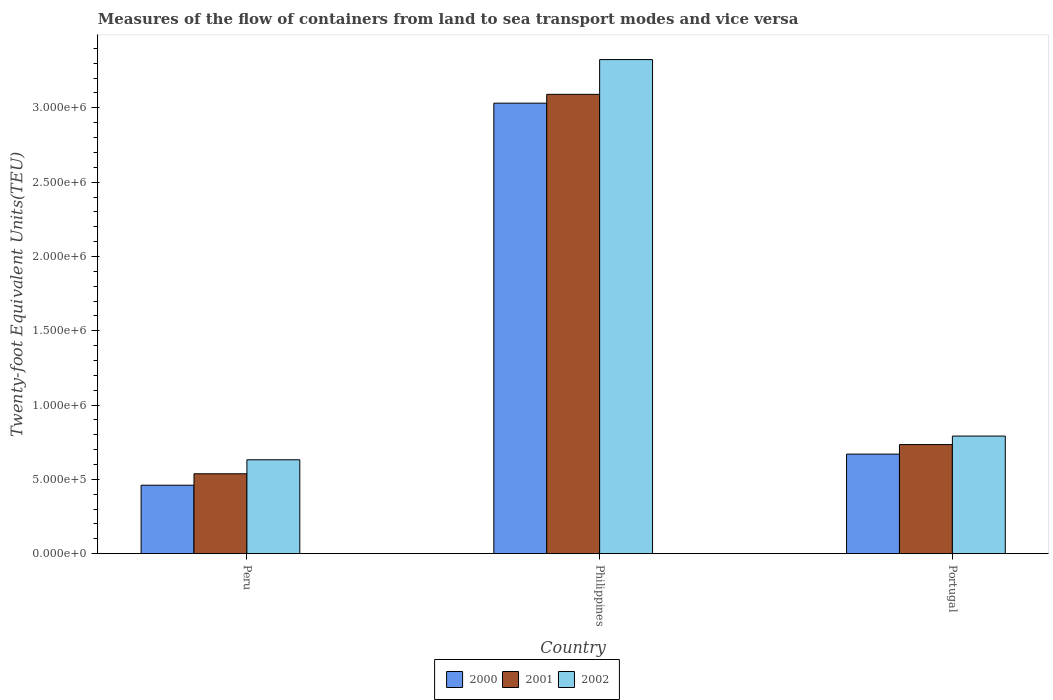How many different coloured bars are there?
Your answer should be compact. 3. Are the number of bars on each tick of the X-axis equal?
Ensure brevity in your answer.  Yes. How many bars are there on the 2nd tick from the left?
Provide a succinct answer. 3. How many bars are there on the 2nd tick from the right?
Your response must be concise. 3. What is the label of the 1st group of bars from the left?
Your answer should be very brief. Peru. What is the container port traffic in 2001 in Portugal?
Provide a short and direct response. 7.34e+05. Across all countries, what is the maximum container port traffic in 2000?
Offer a very short reply. 3.03e+06. Across all countries, what is the minimum container port traffic in 2002?
Your answer should be very brief. 6.32e+05. In which country was the container port traffic in 2001 maximum?
Your answer should be compact. Philippines. In which country was the container port traffic in 2001 minimum?
Provide a succinct answer. Peru. What is the total container port traffic in 2001 in the graph?
Keep it short and to the point. 4.36e+06. What is the difference between the container port traffic in 2000 in Peru and that in Philippines?
Offer a terse response. -2.57e+06. What is the difference between the container port traffic in 2002 in Peru and the container port traffic in 2001 in Portugal?
Offer a very short reply. -1.02e+05. What is the average container port traffic in 2000 per country?
Ensure brevity in your answer.  1.39e+06. What is the difference between the container port traffic of/in 2002 and container port traffic of/in 2000 in Peru?
Provide a short and direct response. 1.71e+05. What is the ratio of the container port traffic in 2000 in Peru to that in Philippines?
Offer a very short reply. 0.15. Is the difference between the container port traffic in 2002 in Peru and Portugal greater than the difference between the container port traffic in 2000 in Peru and Portugal?
Your answer should be very brief. Yes. What is the difference between the highest and the second highest container port traffic in 2000?
Offer a terse response. 2.57e+06. What is the difference between the highest and the lowest container port traffic in 2001?
Your response must be concise. 2.55e+06. Is the sum of the container port traffic in 2002 in Philippines and Portugal greater than the maximum container port traffic in 2000 across all countries?
Provide a succinct answer. Yes. What is the difference between two consecutive major ticks on the Y-axis?
Offer a very short reply. 5.00e+05. Are the values on the major ticks of Y-axis written in scientific E-notation?
Make the answer very short. Yes. Does the graph contain any zero values?
Make the answer very short. No. Does the graph contain grids?
Your answer should be very brief. No. Where does the legend appear in the graph?
Your answer should be compact. Bottom center. How many legend labels are there?
Ensure brevity in your answer.  3. What is the title of the graph?
Make the answer very short. Measures of the flow of containers from land to sea transport modes and vice versa. What is the label or title of the X-axis?
Your answer should be compact. Country. What is the label or title of the Y-axis?
Provide a succinct answer. Twenty-foot Equivalent Units(TEU). What is the Twenty-foot Equivalent Units(TEU) in 2000 in Peru?
Ensure brevity in your answer.  4.61e+05. What is the Twenty-foot Equivalent Units(TEU) in 2001 in Peru?
Ensure brevity in your answer.  5.38e+05. What is the Twenty-foot Equivalent Units(TEU) in 2002 in Peru?
Keep it short and to the point. 6.32e+05. What is the Twenty-foot Equivalent Units(TEU) in 2000 in Philippines?
Offer a very short reply. 3.03e+06. What is the Twenty-foot Equivalent Units(TEU) of 2001 in Philippines?
Provide a succinct answer. 3.09e+06. What is the Twenty-foot Equivalent Units(TEU) in 2002 in Philippines?
Offer a very short reply. 3.32e+06. What is the Twenty-foot Equivalent Units(TEU) of 2000 in Portugal?
Give a very brief answer. 6.70e+05. What is the Twenty-foot Equivalent Units(TEU) of 2001 in Portugal?
Make the answer very short. 7.34e+05. What is the Twenty-foot Equivalent Units(TEU) of 2002 in Portugal?
Provide a short and direct response. 7.91e+05. Across all countries, what is the maximum Twenty-foot Equivalent Units(TEU) of 2000?
Your answer should be compact. 3.03e+06. Across all countries, what is the maximum Twenty-foot Equivalent Units(TEU) in 2001?
Give a very brief answer. 3.09e+06. Across all countries, what is the maximum Twenty-foot Equivalent Units(TEU) of 2002?
Make the answer very short. 3.32e+06. Across all countries, what is the minimum Twenty-foot Equivalent Units(TEU) of 2000?
Provide a short and direct response. 4.61e+05. Across all countries, what is the minimum Twenty-foot Equivalent Units(TEU) of 2001?
Your answer should be very brief. 5.38e+05. Across all countries, what is the minimum Twenty-foot Equivalent Units(TEU) of 2002?
Give a very brief answer. 6.32e+05. What is the total Twenty-foot Equivalent Units(TEU) of 2000 in the graph?
Make the answer very short. 4.16e+06. What is the total Twenty-foot Equivalent Units(TEU) in 2001 in the graph?
Provide a succinct answer. 4.36e+06. What is the total Twenty-foot Equivalent Units(TEU) of 2002 in the graph?
Offer a very short reply. 4.75e+06. What is the difference between the Twenty-foot Equivalent Units(TEU) in 2000 in Peru and that in Philippines?
Offer a terse response. -2.57e+06. What is the difference between the Twenty-foot Equivalent Units(TEU) of 2001 in Peru and that in Philippines?
Keep it short and to the point. -2.55e+06. What is the difference between the Twenty-foot Equivalent Units(TEU) of 2002 in Peru and that in Philippines?
Keep it short and to the point. -2.69e+06. What is the difference between the Twenty-foot Equivalent Units(TEU) in 2000 in Peru and that in Portugal?
Your response must be concise. -2.09e+05. What is the difference between the Twenty-foot Equivalent Units(TEU) of 2001 in Peru and that in Portugal?
Keep it short and to the point. -1.96e+05. What is the difference between the Twenty-foot Equivalent Units(TEU) of 2002 in Peru and that in Portugal?
Provide a short and direct response. -1.60e+05. What is the difference between the Twenty-foot Equivalent Units(TEU) in 2000 in Philippines and that in Portugal?
Your answer should be compact. 2.36e+06. What is the difference between the Twenty-foot Equivalent Units(TEU) of 2001 in Philippines and that in Portugal?
Your answer should be compact. 2.36e+06. What is the difference between the Twenty-foot Equivalent Units(TEU) in 2002 in Philippines and that in Portugal?
Your response must be concise. 2.53e+06. What is the difference between the Twenty-foot Equivalent Units(TEU) in 2000 in Peru and the Twenty-foot Equivalent Units(TEU) in 2001 in Philippines?
Provide a succinct answer. -2.63e+06. What is the difference between the Twenty-foot Equivalent Units(TEU) of 2000 in Peru and the Twenty-foot Equivalent Units(TEU) of 2002 in Philippines?
Your answer should be very brief. -2.86e+06. What is the difference between the Twenty-foot Equivalent Units(TEU) of 2001 in Peru and the Twenty-foot Equivalent Units(TEU) of 2002 in Philippines?
Your answer should be compact. -2.79e+06. What is the difference between the Twenty-foot Equivalent Units(TEU) of 2000 in Peru and the Twenty-foot Equivalent Units(TEU) of 2001 in Portugal?
Offer a terse response. -2.73e+05. What is the difference between the Twenty-foot Equivalent Units(TEU) in 2000 in Peru and the Twenty-foot Equivalent Units(TEU) in 2002 in Portugal?
Keep it short and to the point. -3.31e+05. What is the difference between the Twenty-foot Equivalent Units(TEU) of 2001 in Peru and the Twenty-foot Equivalent Units(TEU) of 2002 in Portugal?
Keep it short and to the point. -2.54e+05. What is the difference between the Twenty-foot Equivalent Units(TEU) in 2000 in Philippines and the Twenty-foot Equivalent Units(TEU) in 2001 in Portugal?
Your answer should be very brief. 2.30e+06. What is the difference between the Twenty-foot Equivalent Units(TEU) of 2000 in Philippines and the Twenty-foot Equivalent Units(TEU) of 2002 in Portugal?
Give a very brief answer. 2.24e+06. What is the difference between the Twenty-foot Equivalent Units(TEU) in 2001 in Philippines and the Twenty-foot Equivalent Units(TEU) in 2002 in Portugal?
Provide a short and direct response. 2.30e+06. What is the average Twenty-foot Equivalent Units(TEU) in 2000 per country?
Ensure brevity in your answer.  1.39e+06. What is the average Twenty-foot Equivalent Units(TEU) of 2001 per country?
Give a very brief answer. 1.45e+06. What is the average Twenty-foot Equivalent Units(TEU) of 2002 per country?
Make the answer very short. 1.58e+06. What is the difference between the Twenty-foot Equivalent Units(TEU) in 2000 and Twenty-foot Equivalent Units(TEU) in 2001 in Peru?
Give a very brief answer. -7.69e+04. What is the difference between the Twenty-foot Equivalent Units(TEU) of 2000 and Twenty-foot Equivalent Units(TEU) of 2002 in Peru?
Your answer should be very brief. -1.71e+05. What is the difference between the Twenty-foot Equivalent Units(TEU) of 2001 and Twenty-foot Equivalent Units(TEU) of 2002 in Peru?
Keep it short and to the point. -9.42e+04. What is the difference between the Twenty-foot Equivalent Units(TEU) of 2000 and Twenty-foot Equivalent Units(TEU) of 2001 in Philippines?
Your response must be concise. -5.94e+04. What is the difference between the Twenty-foot Equivalent Units(TEU) of 2000 and Twenty-foot Equivalent Units(TEU) of 2002 in Philippines?
Your response must be concise. -2.93e+05. What is the difference between the Twenty-foot Equivalent Units(TEU) in 2001 and Twenty-foot Equivalent Units(TEU) in 2002 in Philippines?
Keep it short and to the point. -2.34e+05. What is the difference between the Twenty-foot Equivalent Units(TEU) of 2000 and Twenty-foot Equivalent Units(TEU) of 2001 in Portugal?
Your answer should be compact. -6.40e+04. What is the difference between the Twenty-foot Equivalent Units(TEU) of 2000 and Twenty-foot Equivalent Units(TEU) of 2002 in Portugal?
Give a very brief answer. -1.21e+05. What is the difference between the Twenty-foot Equivalent Units(TEU) of 2001 and Twenty-foot Equivalent Units(TEU) of 2002 in Portugal?
Provide a succinct answer. -5.74e+04. What is the ratio of the Twenty-foot Equivalent Units(TEU) in 2000 in Peru to that in Philippines?
Provide a short and direct response. 0.15. What is the ratio of the Twenty-foot Equivalent Units(TEU) of 2001 in Peru to that in Philippines?
Give a very brief answer. 0.17. What is the ratio of the Twenty-foot Equivalent Units(TEU) in 2002 in Peru to that in Philippines?
Keep it short and to the point. 0.19. What is the ratio of the Twenty-foot Equivalent Units(TEU) of 2000 in Peru to that in Portugal?
Your answer should be very brief. 0.69. What is the ratio of the Twenty-foot Equivalent Units(TEU) in 2001 in Peru to that in Portugal?
Give a very brief answer. 0.73. What is the ratio of the Twenty-foot Equivalent Units(TEU) of 2002 in Peru to that in Portugal?
Ensure brevity in your answer.  0.8. What is the ratio of the Twenty-foot Equivalent Units(TEU) of 2000 in Philippines to that in Portugal?
Offer a terse response. 4.52. What is the ratio of the Twenty-foot Equivalent Units(TEU) of 2001 in Philippines to that in Portugal?
Make the answer very short. 4.21. What is the ratio of the Twenty-foot Equivalent Units(TEU) of 2002 in Philippines to that in Portugal?
Your answer should be compact. 4.2. What is the difference between the highest and the second highest Twenty-foot Equivalent Units(TEU) in 2000?
Your answer should be very brief. 2.36e+06. What is the difference between the highest and the second highest Twenty-foot Equivalent Units(TEU) of 2001?
Offer a very short reply. 2.36e+06. What is the difference between the highest and the second highest Twenty-foot Equivalent Units(TEU) of 2002?
Your answer should be compact. 2.53e+06. What is the difference between the highest and the lowest Twenty-foot Equivalent Units(TEU) in 2000?
Your response must be concise. 2.57e+06. What is the difference between the highest and the lowest Twenty-foot Equivalent Units(TEU) in 2001?
Make the answer very short. 2.55e+06. What is the difference between the highest and the lowest Twenty-foot Equivalent Units(TEU) of 2002?
Provide a short and direct response. 2.69e+06. 